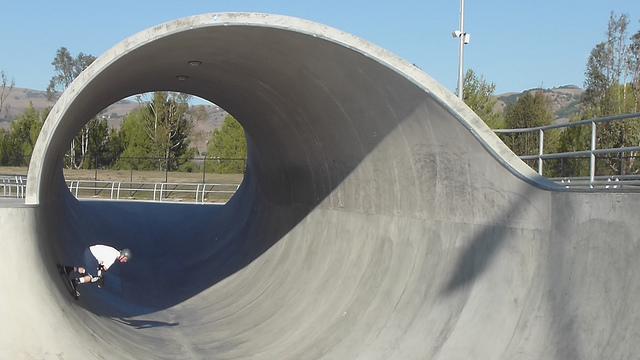Is he the only skater at the park?
Keep it brief. Yes. What do skaters call this structure?
Concise answer only. Pipe. Is he having fun?
Be succinct. Yes. 